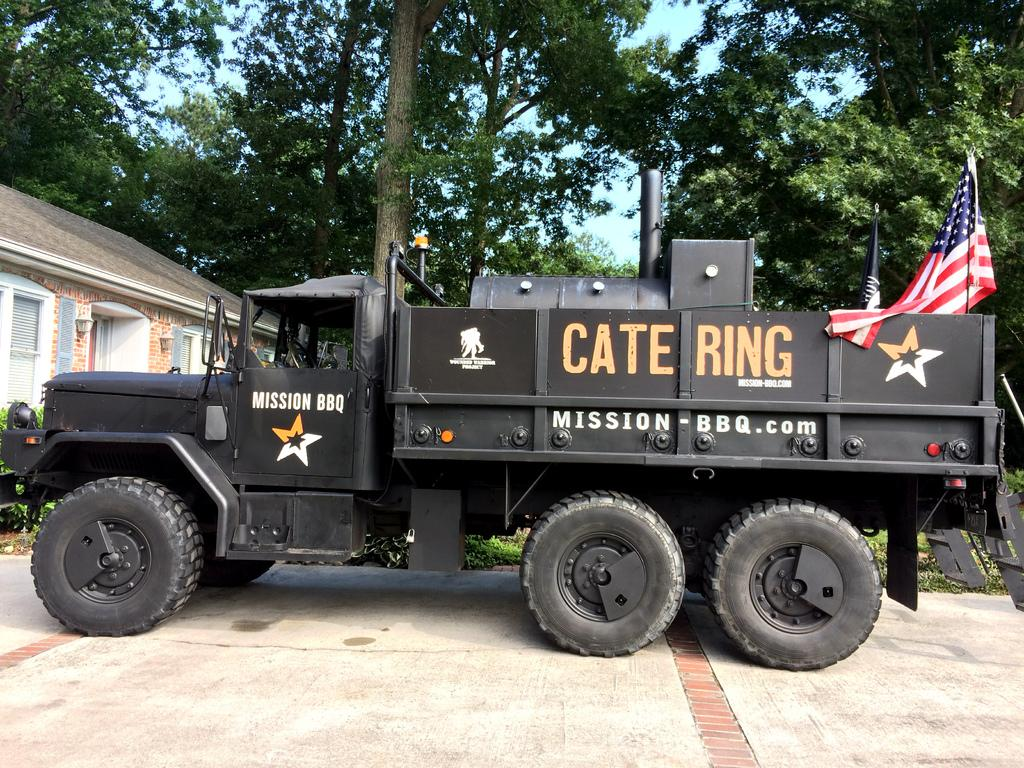What is the main subject of the image? The main subject of the image is a truck on the road. Where is the truck located in the image? The truck is in the middle of the image. What can be seen in the background of the image? There are trees and a house in the background of the image. What is visible at the top of the image? The sky is visible at the top of the image. How does the stove contribute to the scene in the image? There is no stove present in the image. What role does death play in the image? There is no reference to death in the image. 